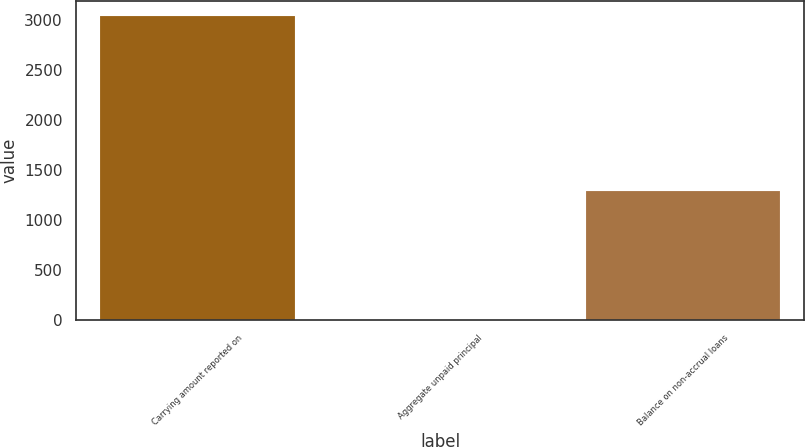Convert chart to OTSL. <chart><loc_0><loc_0><loc_500><loc_500><bar_chart><fcel>Carrying amount reported on<fcel>Aggregate unpaid principal<fcel>Balance on non-accrual loans<nl><fcel>3038<fcel>5<fcel>1292<nl></chart> 